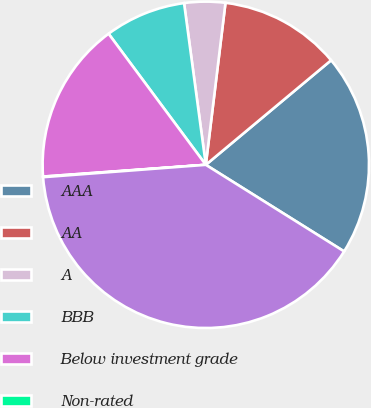Convert chart to OTSL. <chart><loc_0><loc_0><loc_500><loc_500><pie_chart><fcel>AAA<fcel>AA<fcel>A<fcel>BBB<fcel>Below investment grade<fcel>Non-rated<fcel>Total<nl><fcel>19.97%<fcel>12.01%<fcel>4.05%<fcel>8.03%<fcel>15.99%<fcel>0.06%<fcel>39.89%<nl></chart> 